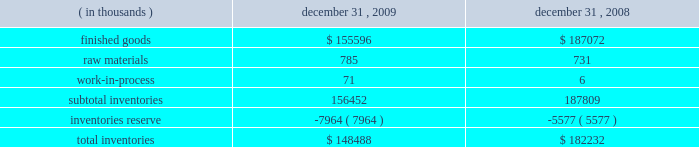To the two-class method .
The provisions of this guidance were required for fiscal years beginning after december 15 , 2008 .
The company has adopted this guidance for current period computations of earnings per share , and has updated prior period computations of earnings per share .
The adoption of this guidance in the first quarter of 2009 did not have a material impact on the company 2019s computation of earnings per share .
Refer to note 11 for further discussion .
In june 2008 , the fasb issued accounting guidance addressing the determination of whether provisions that introduce adjustment features ( including contingent adjustment features ) would prevent treating a derivative contract or an embedded derivative on a company 2019s own stock as indexed solely to the company 2019s stock .
This guidance was effective for fiscal years beginning after december 15 , 2008 .
The adoption of this guidance in the first quarter of 2009 did not have any impact on the company 2019s consolidated financial statements .
In march 2008 , the fasb issued accounting guidance intended to improve financial reporting about derivative instruments and hedging activities by requiring enhanced disclosures to enable investors to better understand their effects on an entity 2019s financial position , financial performance , and cash flows .
This guidance was effective for the fiscal years and interim periods beginning after november 15 , 2008 .
The adoption of this guidance in the first quarter of 2009 did not have any impact on the company 2019s consolidated financial statements .
In december 2007 , the fasb issued replacement guidance that requires the acquirer of a business to recognize and measure the identifiable assets acquired , the liabilities assumed , and any non-controlling interest in the acquired entity at fair value .
This replacement guidance also requires transaction costs related to the business combination to be expensed as incurred .
It was effective for business combinations for which the acquisition date was on or after the start of the fiscal year beginning after december 15 , 2008 .
The adoption of this guidance in the first quarter of 2009 did not have any impact on the company 2019s consolidated financial statements .
In december 2007 , the fasb issued accounting guidance that establishes accounting and reporting standards for the noncontrolling interest in a subsidiary and for the deconsolidation of a subsidiary .
This guidance was effective for fiscal years beginning after december 15 , 2008 .
The adoption of this guidance in the first quarter of 2009 did not have any impact on the company 2019s consolidated financial statements .
In september 2006 , the fasb issued accounting guidance which defines fair value , establishes a framework for measuring fair value in accordance with generally accepted accounting principles and expands disclosures about fair value measurements .
This guidance was effective for fiscal years beginning after november 15 , 2007 , however the fasb delayed the effective date to fiscal years beginning after november 15 , 2008 for nonfinancial assets and nonfinancial liabilities , except those items recognized or disclosed at fair value on an annual or more frequent basis .
The adoption of this guidance for nonfinancial assets and liabilities in the first quarter of 2009 did not have any impact on the company 2019s consolidated financial statements .
Inventories inventories consisted of the following: .

What was the percent of the change in the inventory reserve from 2008 to 2009? 
Rationale: the inventory reserve increased by 42.8% from 2008 to 2009
Computations: ((7964 - 5577) / 5577)
Answer: 0.42801. 